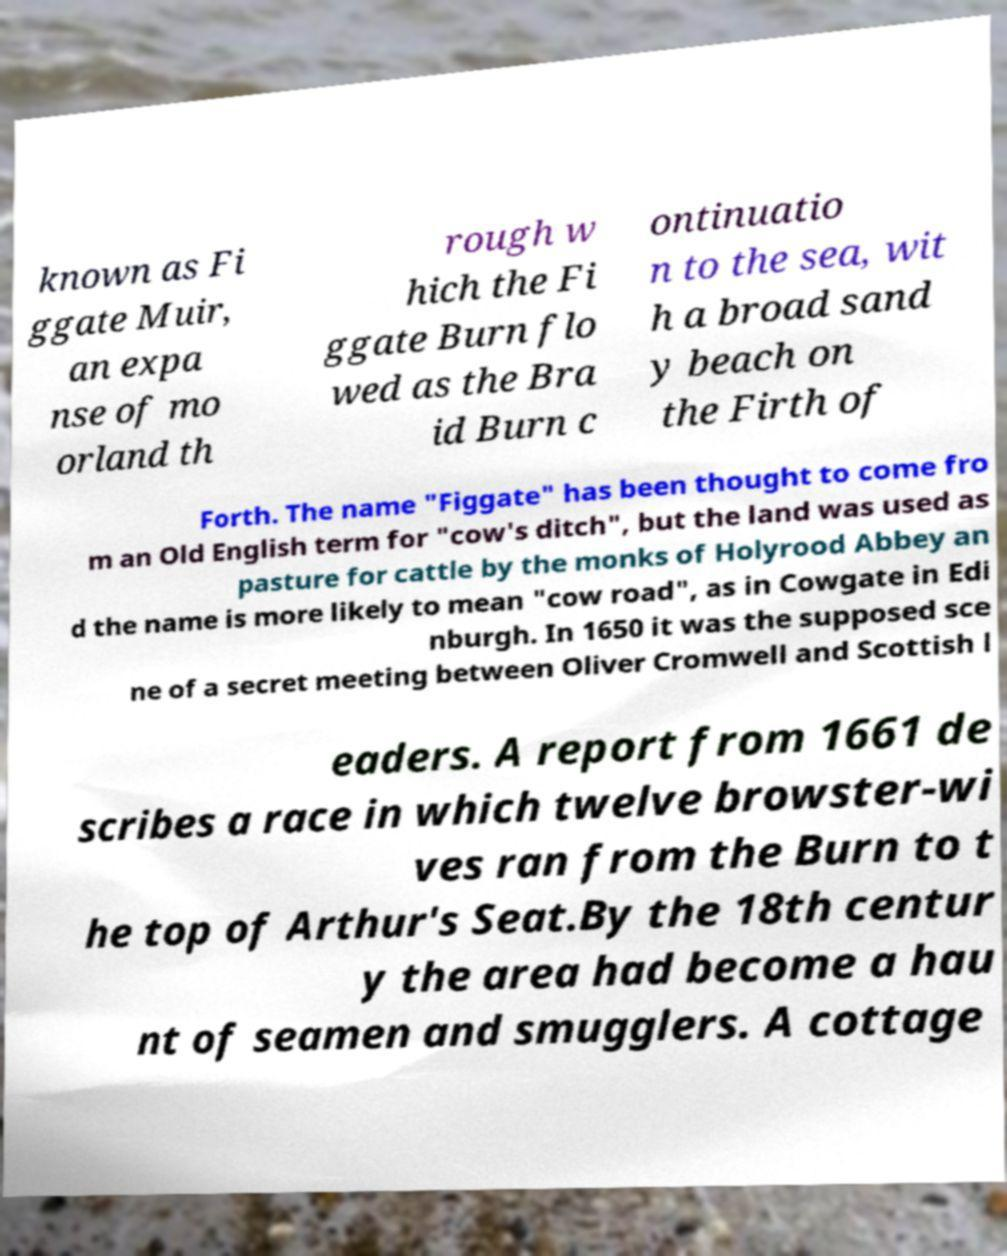Can you read and provide the text displayed in the image?This photo seems to have some interesting text. Can you extract and type it out for me? known as Fi ggate Muir, an expa nse of mo orland th rough w hich the Fi ggate Burn flo wed as the Bra id Burn c ontinuatio n to the sea, wit h a broad sand y beach on the Firth of Forth. The name "Figgate" has been thought to come fro m an Old English term for "cow's ditch", but the land was used as pasture for cattle by the monks of Holyrood Abbey an d the name is more likely to mean "cow road", as in Cowgate in Edi nburgh. In 1650 it was the supposed sce ne of a secret meeting between Oliver Cromwell and Scottish l eaders. A report from 1661 de scribes a race in which twelve browster-wi ves ran from the Burn to t he top of Arthur's Seat.By the 18th centur y the area had become a hau nt of seamen and smugglers. A cottage 